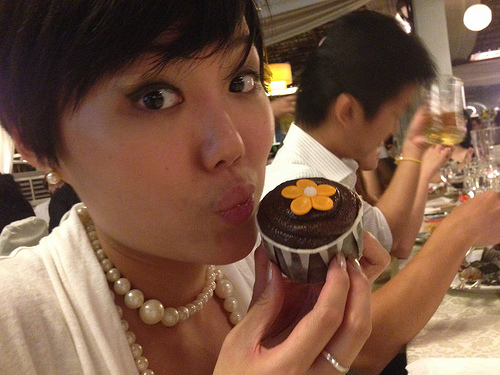Which side of the image is the beer on? The beer is on the right side of the image. 